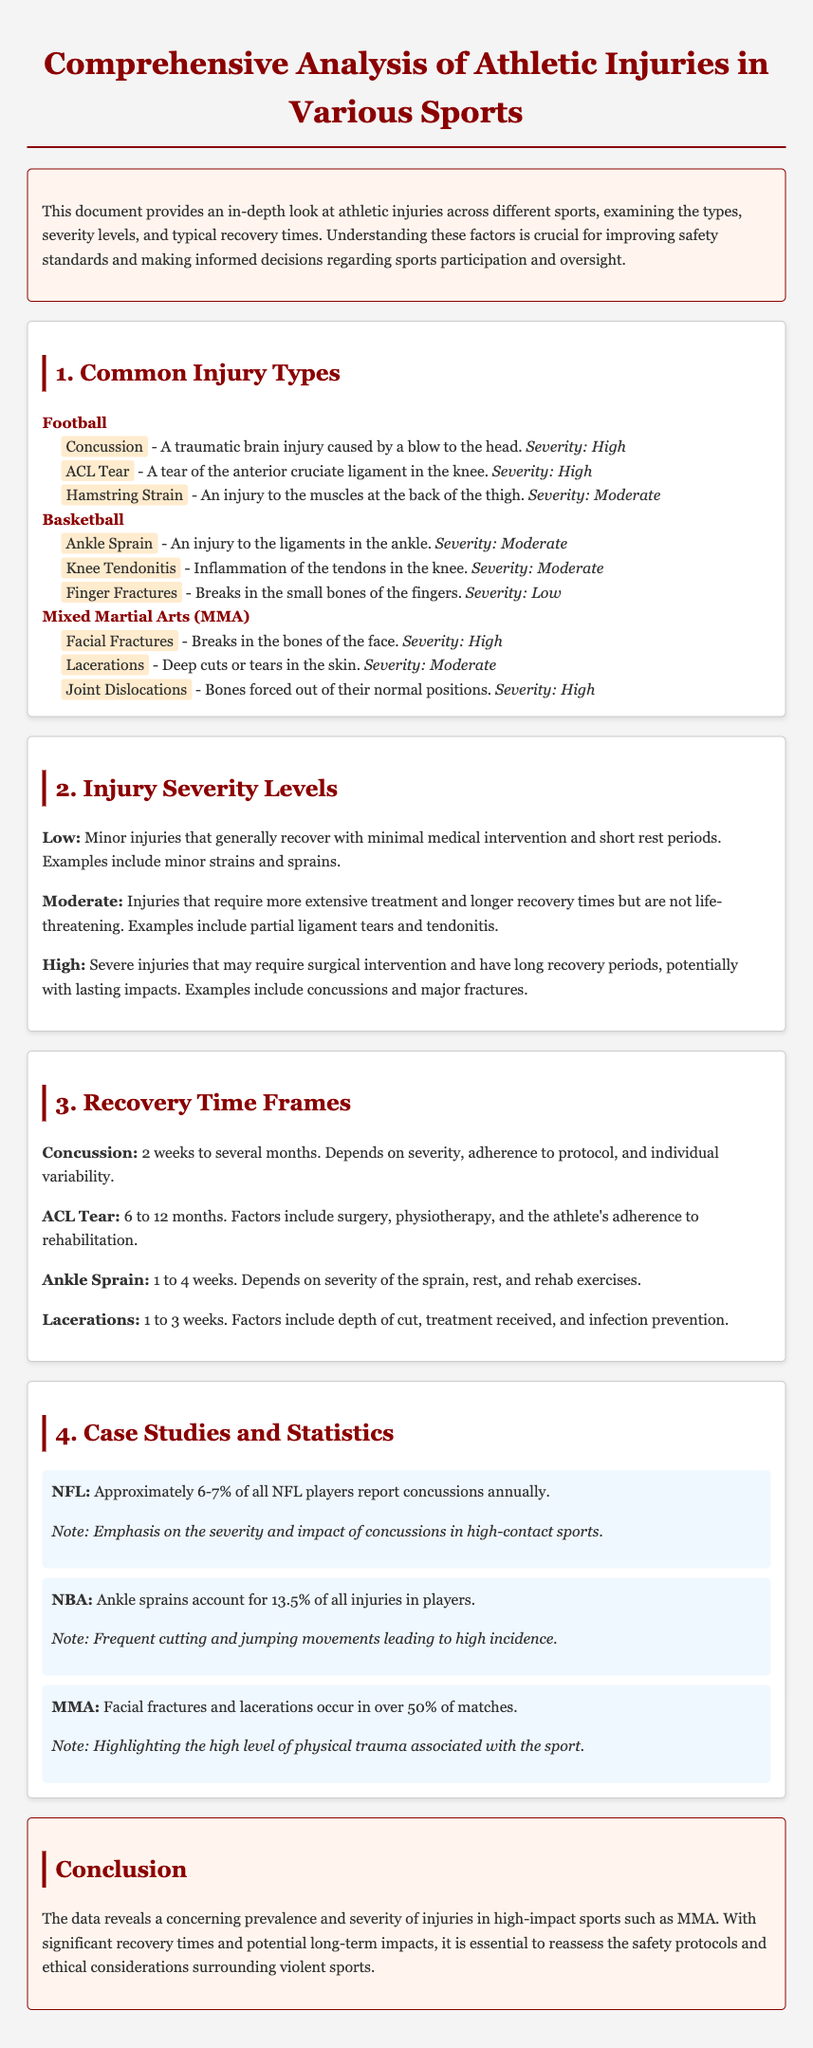What is the severity level of concussion in football? The document states that a concussion is classified as having a high severity level in football.
Answer: High How many weeks is the recovery time for an ankle sprain? According to the document, the recovery time for an ankle sprain is noted to be 1 to 4 weeks.
Answer: 1 to 4 weeks What percentage of MMA matches involve facial fractures and lacerations? The document indicates that facial fractures and lacerations occur in over 50% of MMA matches.
Answer: Over 50% Which injury type is categorized as moderate in basketball? The document lists ankle sprains, knee tendonitis, and finger fractures as injuries in basketball; ankle sprains and knee tendonitis are classified as moderate.
Answer: Ankle Sprain (or Knee Tendonitis) What is the primary finding regarding NFL concussions? The document reveals that approximately 6-7% of all NFL players report concussions annually, highlighting the severity and impact of concussions.
Answer: Approximately 6-7% What is the main concern raised in the conclusion of the document? The conclusion emphasizes the concerning prevalence and severity of injuries, particularly in MMA, and suggests the need to reassess safety protocols and ethical considerations.
Answer: Safety protocols and ethical considerations How is an ACL tear classified in terms of severity? The document specifies that an ACL tear is classified as having a high severity level.
Answer: High 